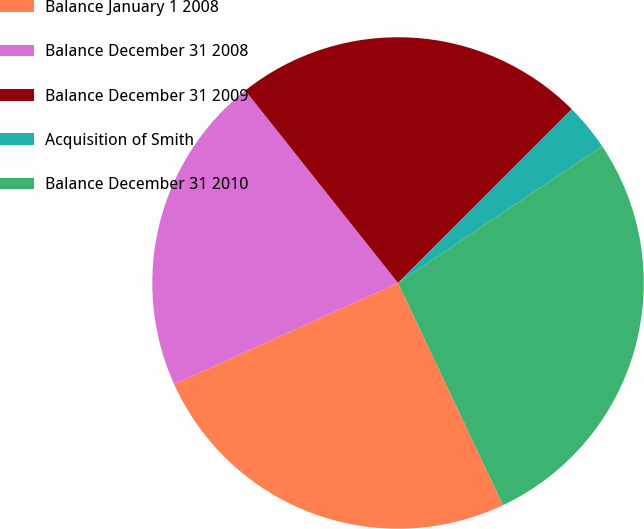Convert chart to OTSL. <chart><loc_0><loc_0><loc_500><loc_500><pie_chart><fcel>Balance January 1 2008<fcel>Balance December 31 2008<fcel>Balance December 31 2009<fcel>Acquisition of Smith<fcel>Balance December 31 2010<nl><fcel>25.27%<fcel>21.08%<fcel>23.18%<fcel>3.11%<fcel>27.36%<nl></chart> 